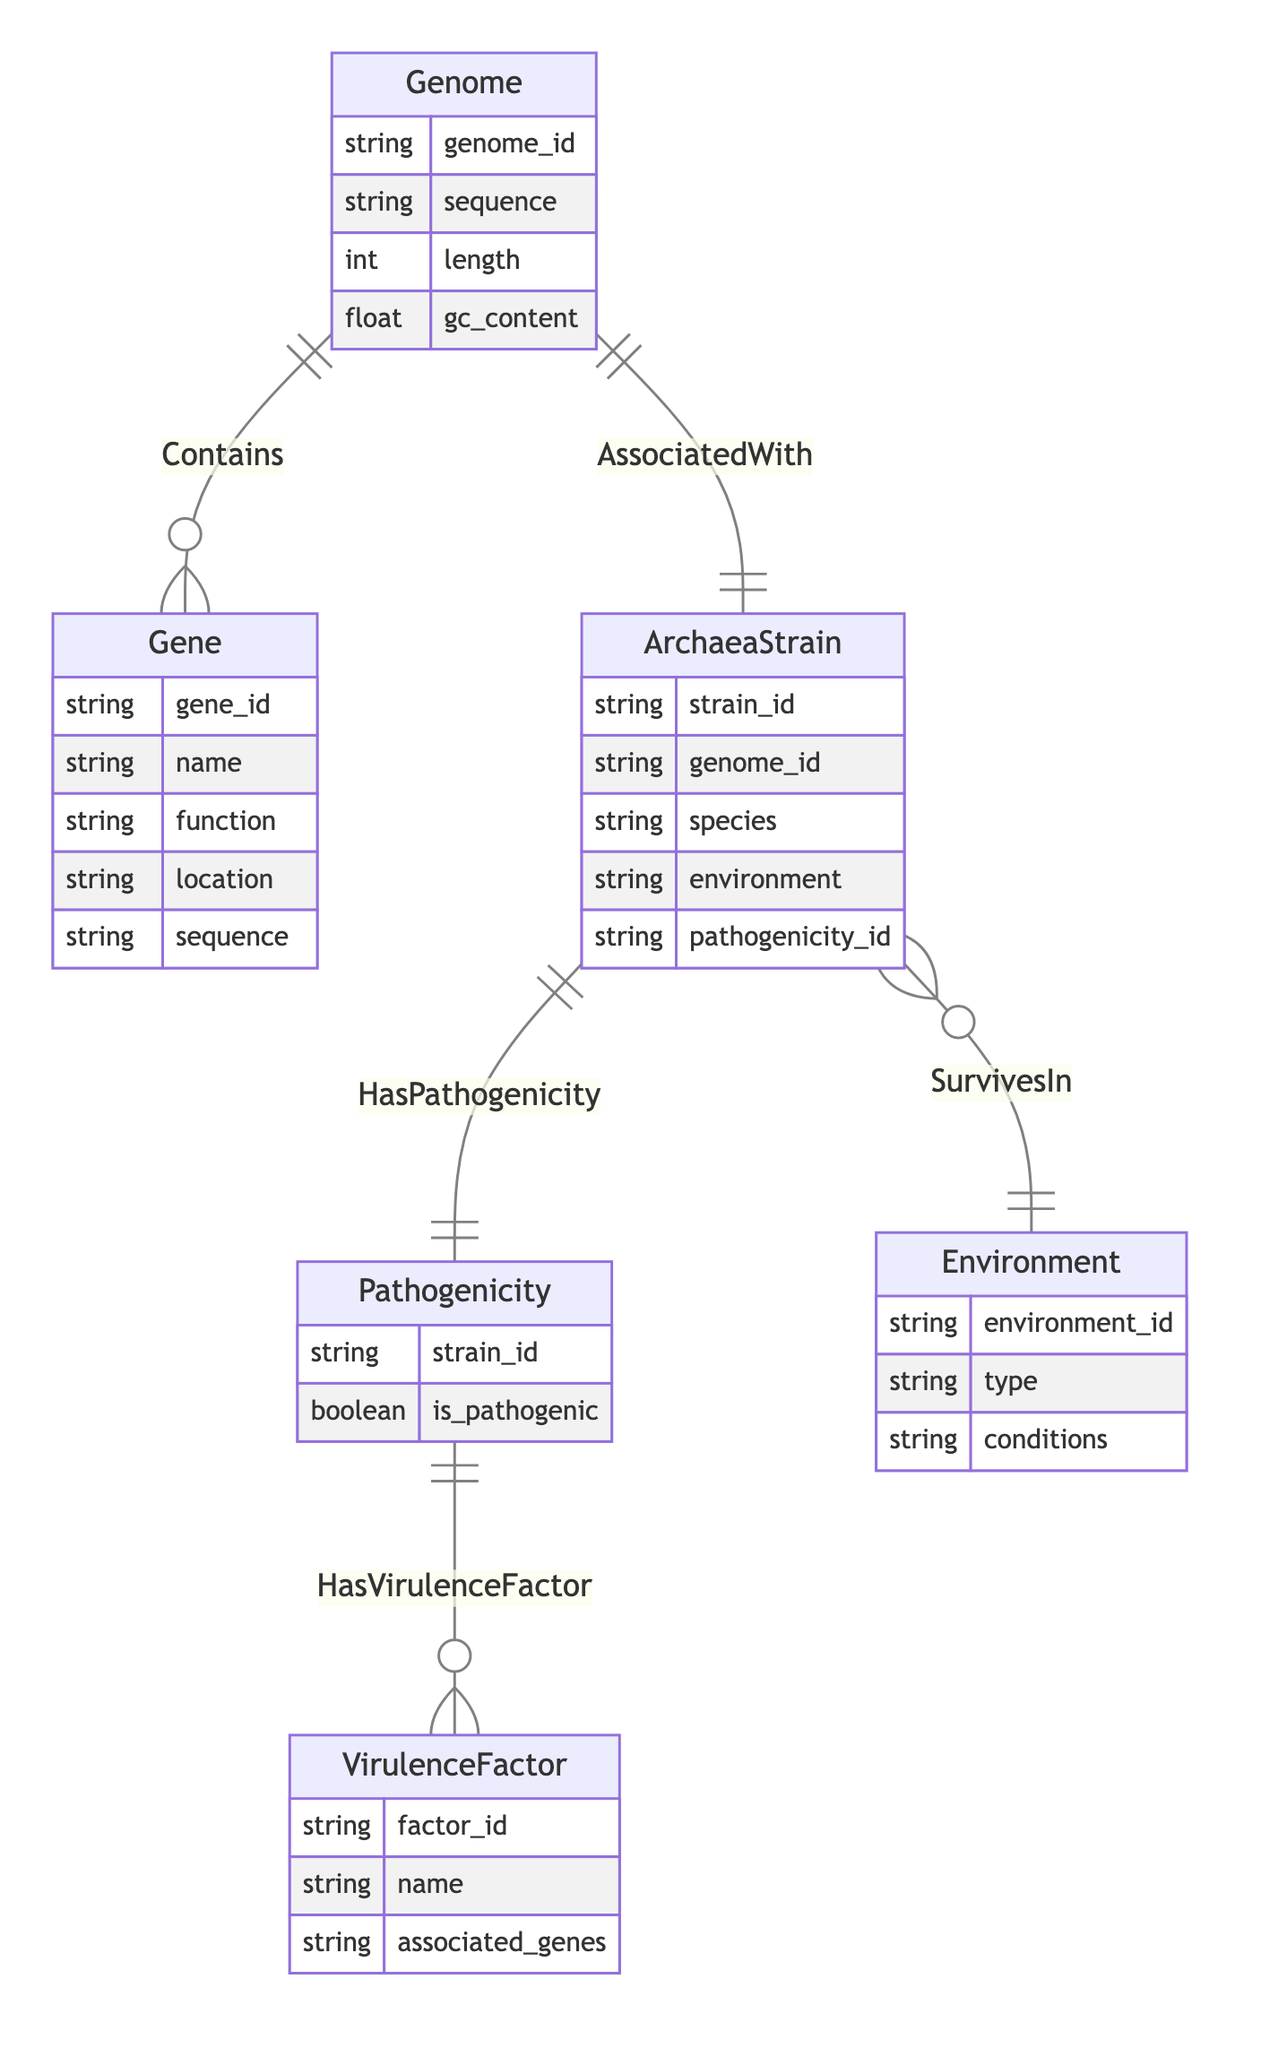What is the primary relationship between Genome and Gene? The diagram shows that the relationship between Genome and Gene is labeled as "Contains," which indicates that each Genome can contain multiple Genes (noted by the cardinality of one to many).
Answer: Contains How many entities are present in the diagram? By counting the distinct entity names listed, we find there are six entities: Genome, Gene, Pathogenicity, ArchaeaStrain, VirulenceFactor, and Environment.
Answer: 6 What is the cardinality of the relationship between ArchaeaStrain and Pathogenicity? The relationship between ArchaeaStrain and Pathogenicity is labeled "HasPathogenicity," which shows a cardinality of one to one, meaning each ArchaeaStrain corresponds to exactly one Pathogenicity.
Answer: One to one What entities have a many relationship with ArchaeaStrain? The diagram indicates that ArchaeaStrain has a many-to-one relationship with Environment (SurvivesIn) and a one-to-one relationship with Pathogenicity (HasPathogenicity), so it is associated many times with the Environment entity.
Answer: Environment Which entity includes the attribute "gc_content"? The attribute "gc_content" is found in the Genome entity, indicating a characteristic of the genome sequences managed within that entity.
Answer: Genome How many virulence factors can be associated with a single Pathogenicity? The relationship "HasVirulenceFactor" is shown as one to many, indicating that one Pathogenicity can be associated with multiple VirulenceFactors.
Answer: Many What does the ArchaeaStrain entity represent in this diagram? The ArchaeaStrain entity represents strains of Archaea, characterized by attributes such as strain_id, genome_id, species, environment, and pathogenicity_id, capturing its key features and associations.
Answer: Strains of Archaea Is it possible for a single Environment to be associated with multiple ArchaeaStrains? Yes, the relationship "SurvivesIn" indicates a many-to-one relationship, meaning multiple ArchaeaStrains can survive in the same Environment, supporting diverse microbial habitats.
Answer: Yes Which entity would you associate with the gene "name"? The "name" attribute is part of the Gene entity, indicating that each gene will have a designated name representing its identity or classification.
Answer: Gene 